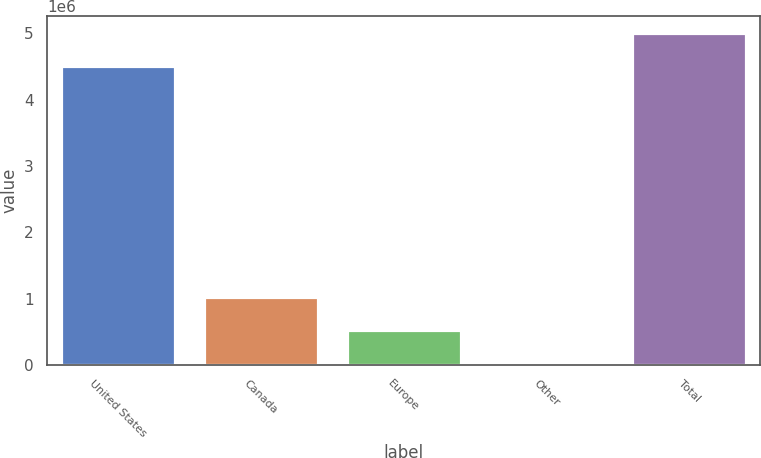Convert chart. <chart><loc_0><loc_0><loc_500><loc_500><bar_chart><fcel>United States<fcel>Canada<fcel>Europe<fcel>Other<fcel>Total<nl><fcel>4.51281e+06<fcel>1.02009e+06<fcel>526920<fcel>33749<fcel>5.00598e+06<nl></chart> 